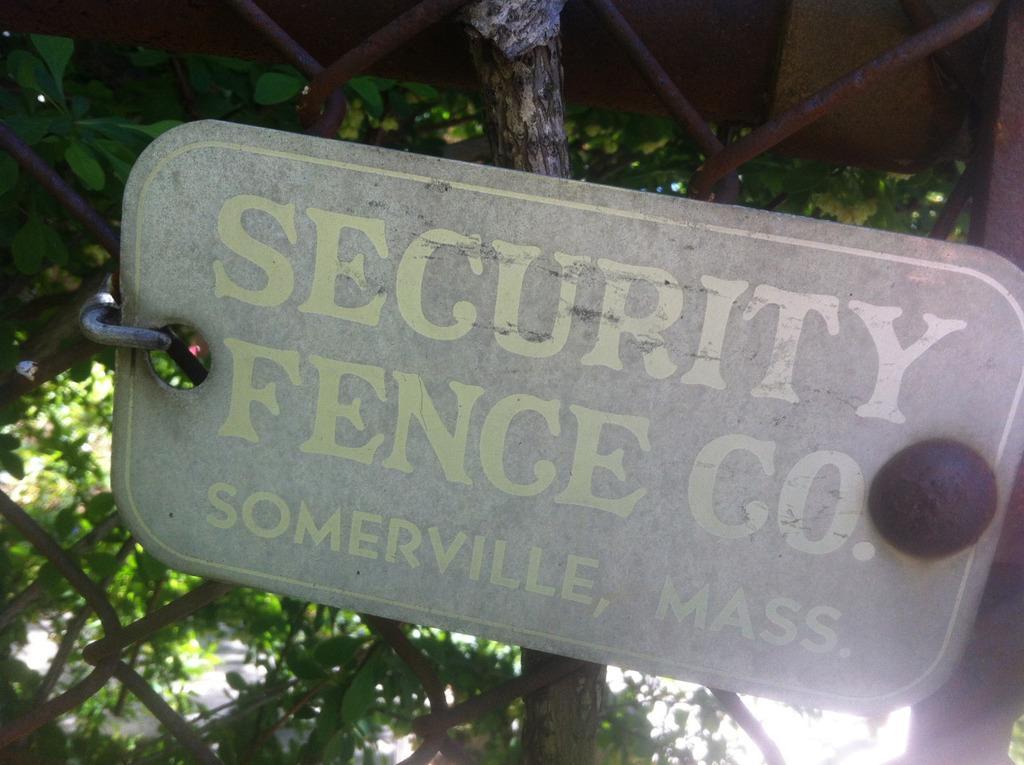How would you summarize this image in a sentence or two? In this image we can see a board in which there are some words written, there is fencing and in the background of the image there are some trees. 